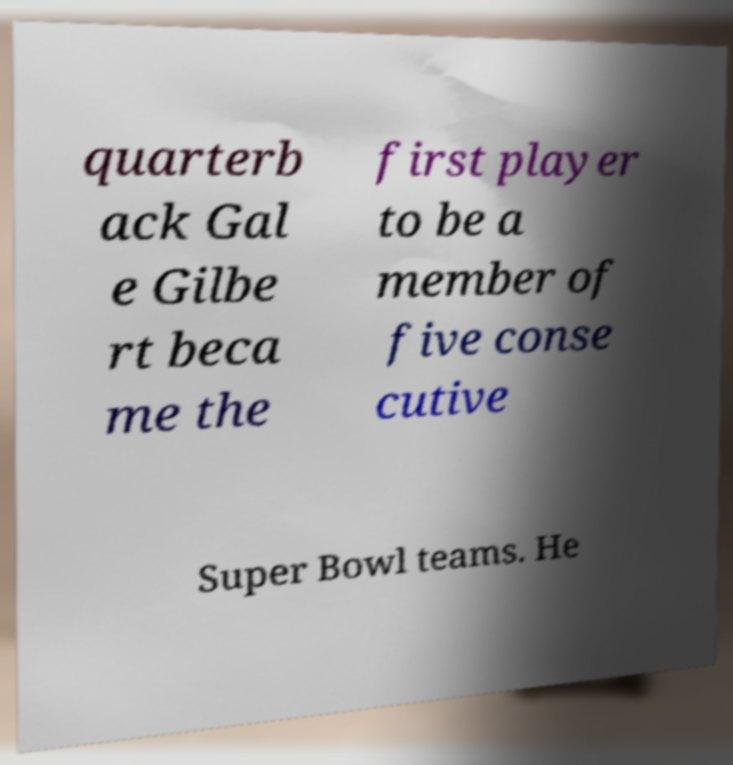Can you read and provide the text displayed in the image?This photo seems to have some interesting text. Can you extract and type it out for me? quarterb ack Gal e Gilbe rt beca me the first player to be a member of five conse cutive Super Bowl teams. He 